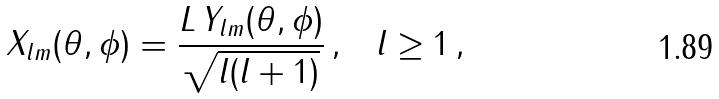<formula> <loc_0><loc_0><loc_500><loc_500>X _ { l m } ( \theta , \phi ) = \frac { L \, Y _ { l m } ( \theta , \phi ) } { \sqrt { l ( l + 1 ) } } \, { , } \quad l \geq 1 \, { , }</formula> 